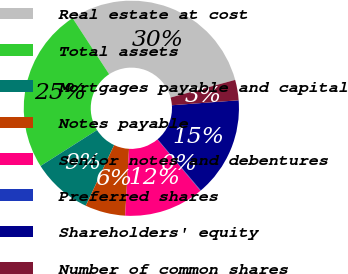Convert chart to OTSL. <chart><loc_0><loc_0><loc_500><loc_500><pie_chart><fcel>Real estate at cost<fcel>Total assets<fcel>Mortgages payable and capital<fcel>Notes payable<fcel>Senior notes and debentures<fcel>Preferred shares<fcel>Shareholders' equity<fcel>Number of common shares<nl><fcel>29.95%<fcel>24.81%<fcel>9.03%<fcel>6.04%<fcel>12.02%<fcel>0.07%<fcel>15.01%<fcel>3.06%<nl></chart> 